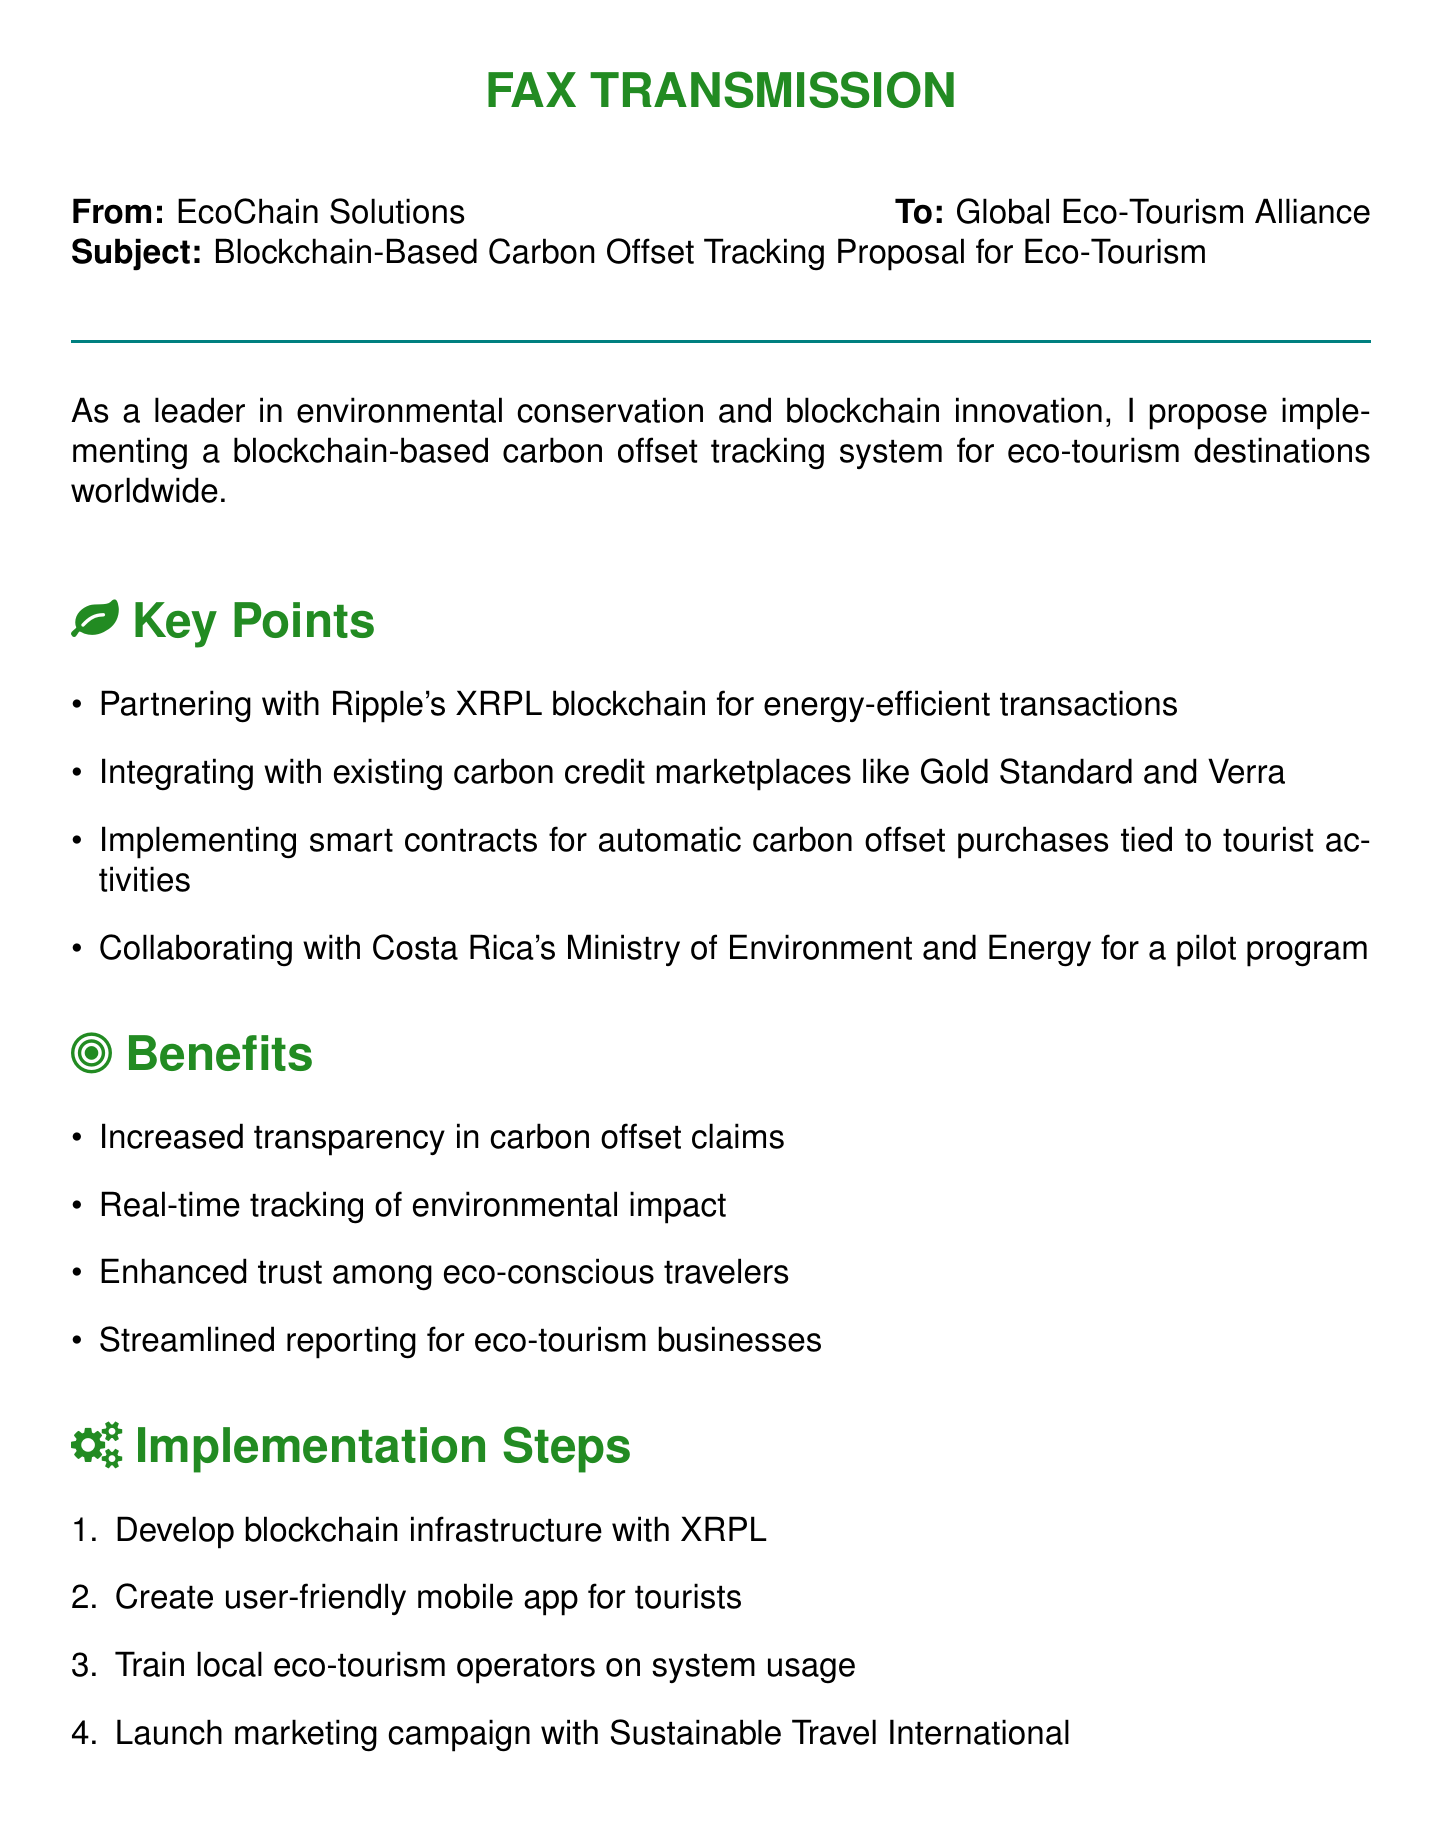What is the subject of the fax? The subject of the fax is a proposal for implementing a blockchain-based carbon offset tracking system for eco-tourism.
Answer: Blockchain-Based Carbon Offset Tracking Proposal for Eco-Tourism Who is the sender of the fax? The sender of the fax is mentioned at the beginning as EcoChain Solutions.
Answer: EcoChain Solutions Which blockchain is proposed for partnership? The proposal mentions partnering with Ripple's XRPL blockchain.
Answer: Ripple's XRPL blockchain What is one of the benefits listed in the document? The document outlines several benefits, one of them being increased transparency in carbon offset claims.
Answer: Increased transparency in carbon offset claims How many implementation steps are proposed? The document lists four steps in its implementation section.
Answer: 4 What type of contracts will be implemented for carbon offset purchases? The document states that smart contracts will be implemented for this purpose.
Answer: Smart contracts Who is the recipient of the fax? The recipient of the fax is listed as the Global Eco-Tourism Alliance.
Answer: Global Eco-Tourism Alliance What is the name of the founder of EcoChain Solutions? The founder of EcoChain Solutions is mentioned as Dr. Amelia Greenwood.
Answer: Dr. Amelia Greenwood What is suggested for the marketing campaign? The document suggests launching a marketing campaign with Sustainable Travel International.
Answer: Sustainable Travel International 